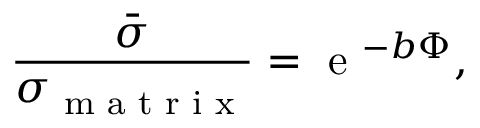<formula> <loc_0><loc_0><loc_500><loc_500>\frac { \bar { \sigma } } { \sigma _ { m a t r i x } } = e ^ { - b \Phi } ,</formula> 